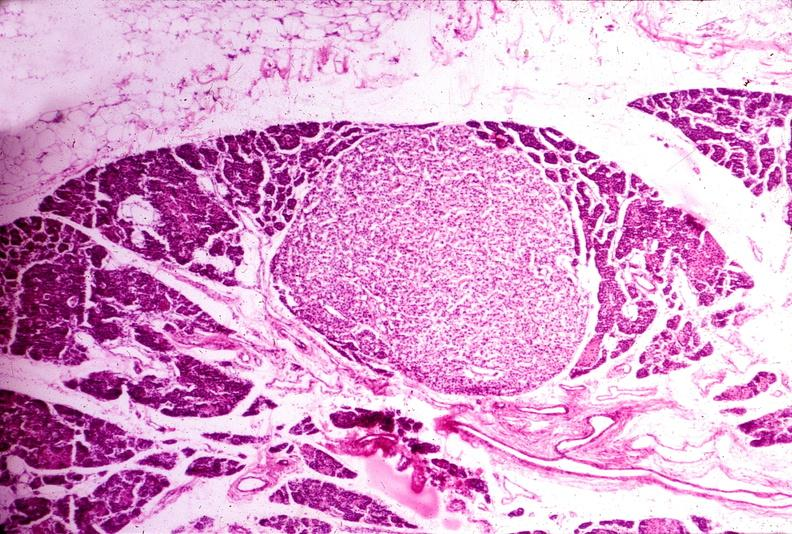what does this image show?
Answer the question using a single word or phrase. Parathyroid adenoma 